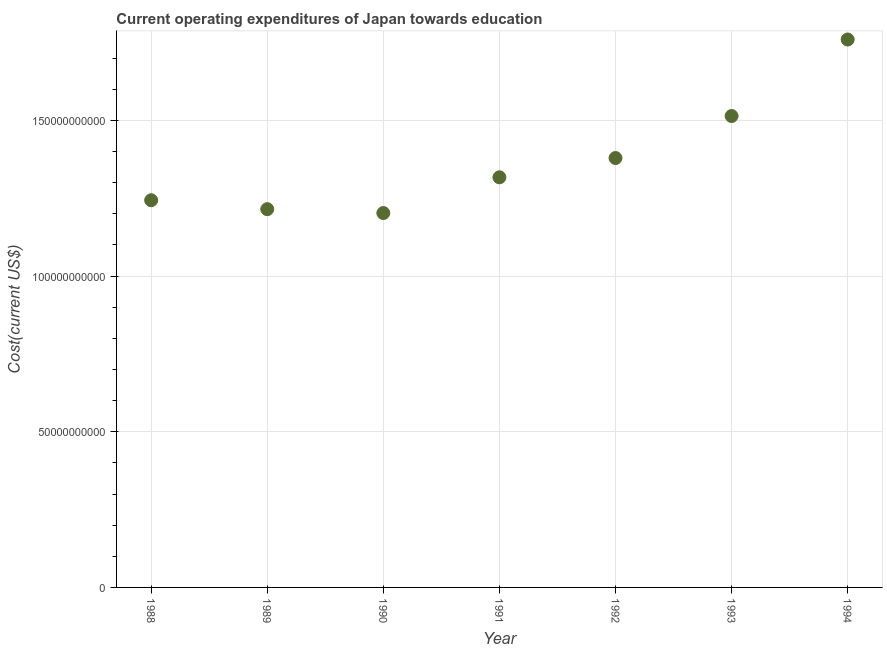What is the education expenditure in 1994?
Your answer should be very brief. 1.76e+11. Across all years, what is the maximum education expenditure?
Your answer should be compact. 1.76e+11. Across all years, what is the minimum education expenditure?
Make the answer very short. 1.20e+11. In which year was the education expenditure maximum?
Give a very brief answer. 1994. What is the sum of the education expenditure?
Your answer should be very brief. 9.63e+11. What is the difference between the education expenditure in 1989 and 1991?
Keep it short and to the point. -1.02e+1. What is the average education expenditure per year?
Your answer should be compact. 1.38e+11. What is the median education expenditure?
Provide a short and direct response. 1.32e+11. Do a majority of the years between 1990 and 1988 (inclusive) have education expenditure greater than 30000000000 US$?
Offer a very short reply. No. What is the ratio of the education expenditure in 1993 to that in 1994?
Your answer should be very brief. 0.86. Is the education expenditure in 1990 less than that in 1994?
Your response must be concise. Yes. Is the difference between the education expenditure in 1988 and 1991 greater than the difference between any two years?
Keep it short and to the point. No. What is the difference between the highest and the second highest education expenditure?
Your response must be concise. 2.46e+1. Is the sum of the education expenditure in 1989 and 1994 greater than the maximum education expenditure across all years?
Your answer should be very brief. Yes. What is the difference between the highest and the lowest education expenditure?
Your answer should be very brief. 5.57e+1. In how many years, is the education expenditure greater than the average education expenditure taken over all years?
Provide a short and direct response. 3. Does the education expenditure monotonically increase over the years?
Provide a short and direct response. No. How many dotlines are there?
Your response must be concise. 1. How many years are there in the graph?
Keep it short and to the point. 7. Does the graph contain grids?
Offer a terse response. Yes. What is the title of the graph?
Your response must be concise. Current operating expenditures of Japan towards education. What is the label or title of the X-axis?
Provide a succinct answer. Year. What is the label or title of the Y-axis?
Make the answer very short. Cost(current US$). What is the Cost(current US$) in 1988?
Your response must be concise. 1.24e+11. What is the Cost(current US$) in 1989?
Make the answer very short. 1.22e+11. What is the Cost(current US$) in 1990?
Ensure brevity in your answer.  1.20e+11. What is the Cost(current US$) in 1991?
Provide a short and direct response. 1.32e+11. What is the Cost(current US$) in 1992?
Provide a short and direct response. 1.38e+11. What is the Cost(current US$) in 1993?
Give a very brief answer. 1.51e+11. What is the Cost(current US$) in 1994?
Make the answer very short. 1.76e+11. What is the difference between the Cost(current US$) in 1988 and 1989?
Offer a very short reply. 2.87e+09. What is the difference between the Cost(current US$) in 1988 and 1990?
Ensure brevity in your answer.  4.11e+09. What is the difference between the Cost(current US$) in 1988 and 1991?
Make the answer very short. -7.37e+09. What is the difference between the Cost(current US$) in 1988 and 1992?
Keep it short and to the point. -1.36e+1. What is the difference between the Cost(current US$) in 1988 and 1993?
Your answer should be compact. -2.71e+1. What is the difference between the Cost(current US$) in 1988 and 1994?
Your answer should be compact. -5.16e+1. What is the difference between the Cost(current US$) in 1989 and 1990?
Provide a succinct answer. 1.24e+09. What is the difference between the Cost(current US$) in 1989 and 1991?
Your answer should be very brief. -1.02e+1. What is the difference between the Cost(current US$) in 1989 and 1992?
Provide a succinct answer. -1.64e+1. What is the difference between the Cost(current US$) in 1989 and 1993?
Ensure brevity in your answer.  -2.99e+1. What is the difference between the Cost(current US$) in 1989 and 1994?
Give a very brief answer. -5.45e+1. What is the difference between the Cost(current US$) in 1990 and 1991?
Your answer should be compact. -1.15e+1. What is the difference between the Cost(current US$) in 1990 and 1992?
Your answer should be compact. -1.77e+1. What is the difference between the Cost(current US$) in 1990 and 1993?
Provide a short and direct response. -3.12e+1. What is the difference between the Cost(current US$) in 1990 and 1994?
Keep it short and to the point. -5.57e+1. What is the difference between the Cost(current US$) in 1991 and 1992?
Offer a very short reply. -6.19e+09. What is the difference between the Cost(current US$) in 1991 and 1993?
Your response must be concise. -1.97e+1. What is the difference between the Cost(current US$) in 1991 and 1994?
Offer a terse response. -4.43e+1. What is the difference between the Cost(current US$) in 1992 and 1993?
Your answer should be compact. -1.35e+1. What is the difference between the Cost(current US$) in 1992 and 1994?
Keep it short and to the point. -3.81e+1. What is the difference between the Cost(current US$) in 1993 and 1994?
Ensure brevity in your answer.  -2.46e+1. What is the ratio of the Cost(current US$) in 1988 to that in 1989?
Offer a very short reply. 1.02. What is the ratio of the Cost(current US$) in 1988 to that in 1990?
Provide a succinct answer. 1.03. What is the ratio of the Cost(current US$) in 1988 to that in 1991?
Provide a succinct answer. 0.94. What is the ratio of the Cost(current US$) in 1988 to that in 1992?
Your response must be concise. 0.9. What is the ratio of the Cost(current US$) in 1988 to that in 1993?
Your answer should be compact. 0.82. What is the ratio of the Cost(current US$) in 1988 to that in 1994?
Provide a succinct answer. 0.71. What is the ratio of the Cost(current US$) in 1989 to that in 1990?
Provide a short and direct response. 1.01. What is the ratio of the Cost(current US$) in 1989 to that in 1991?
Give a very brief answer. 0.92. What is the ratio of the Cost(current US$) in 1989 to that in 1992?
Your answer should be very brief. 0.88. What is the ratio of the Cost(current US$) in 1989 to that in 1993?
Give a very brief answer. 0.8. What is the ratio of the Cost(current US$) in 1989 to that in 1994?
Ensure brevity in your answer.  0.69. What is the ratio of the Cost(current US$) in 1990 to that in 1991?
Give a very brief answer. 0.91. What is the ratio of the Cost(current US$) in 1990 to that in 1992?
Ensure brevity in your answer.  0.87. What is the ratio of the Cost(current US$) in 1990 to that in 1993?
Your answer should be very brief. 0.79. What is the ratio of the Cost(current US$) in 1990 to that in 1994?
Your answer should be very brief. 0.68. What is the ratio of the Cost(current US$) in 1991 to that in 1992?
Ensure brevity in your answer.  0.95. What is the ratio of the Cost(current US$) in 1991 to that in 1993?
Your response must be concise. 0.87. What is the ratio of the Cost(current US$) in 1991 to that in 1994?
Provide a succinct answer. 0.75. What is the ratio of the Cost(current US$) in 1992 to that in 1993?
Your answer should be compact. 0.91. What is the ratio of the Cost(current US$) in 1992 to that in 1994?
Your answer should be very brief. 0.78. What is the ratio of the Cost(current US$) in 1993 to that in 1994?
Make the answer very short. 0.86. 